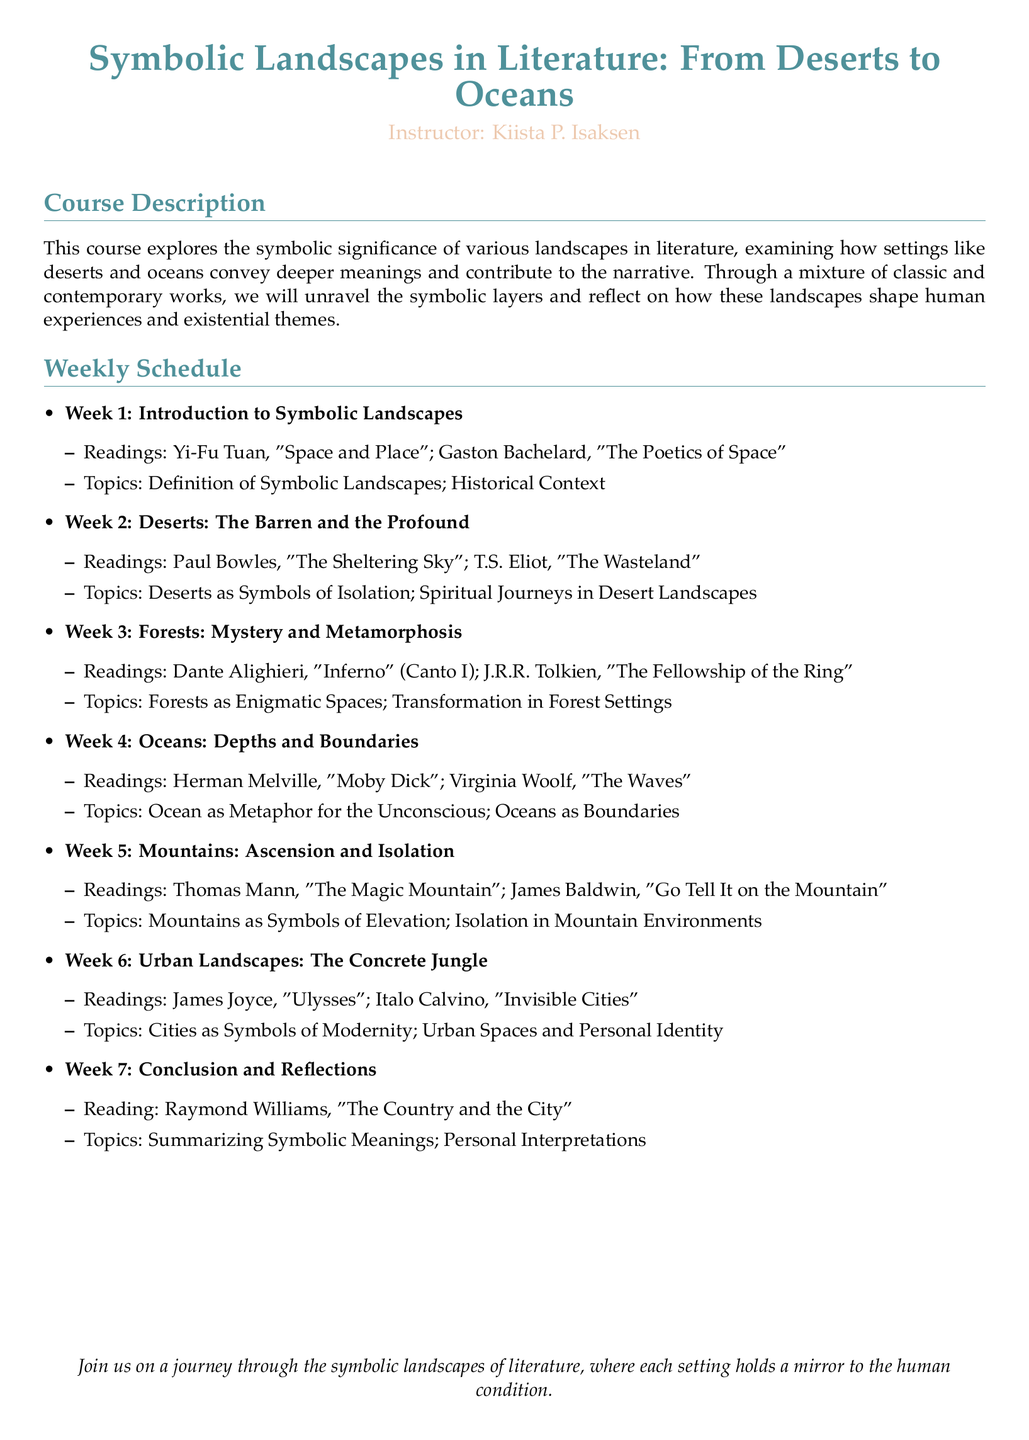What is the title of the course? The title of the course is clearly stated at the top of the document.
Answer: Symbolic Landscapes in Literature: From Deserts to Oceans Who is the instructor? The instructor's name is presented right below the course title.
Answer: Kiista P. Isaksen What is the topic of Week 2? The topic for Week 2 is listed under the corresponding week section.
Answer: Deserts as Symbols of Isolation; Spiritual Journeys in Desert Landscapes What readings are assigned for Week 4? The readings for Week 4 are detailed in the schedule.
Answer: Herman Melville, "Moby Dick"; Virginia Woolf, "The Waves" How many weeks does this course cover? The number of weeks is indicated in the weekly schedule section.
Answer: Seven weeks What is the theme of the concluding week? The main focus for conclusion is stated towards the end of the schedule.
Answer: Summarizing Symbolic Meanings; Personal Interpretations Which author is associated with the reading for Week 6? The assigned readings list the authors corresponding to each week.
Answer: James Joyce What symbolizes modernity according to Week 6 topics? The themes discussed in Week 6 provide insights into urban landscapes.
Answer: Cities What reading is suggested for Week 7? The specific reading for the concluding week is mentioned in the schedule.
Answer: Raymond Williams, "The Country and the City" 